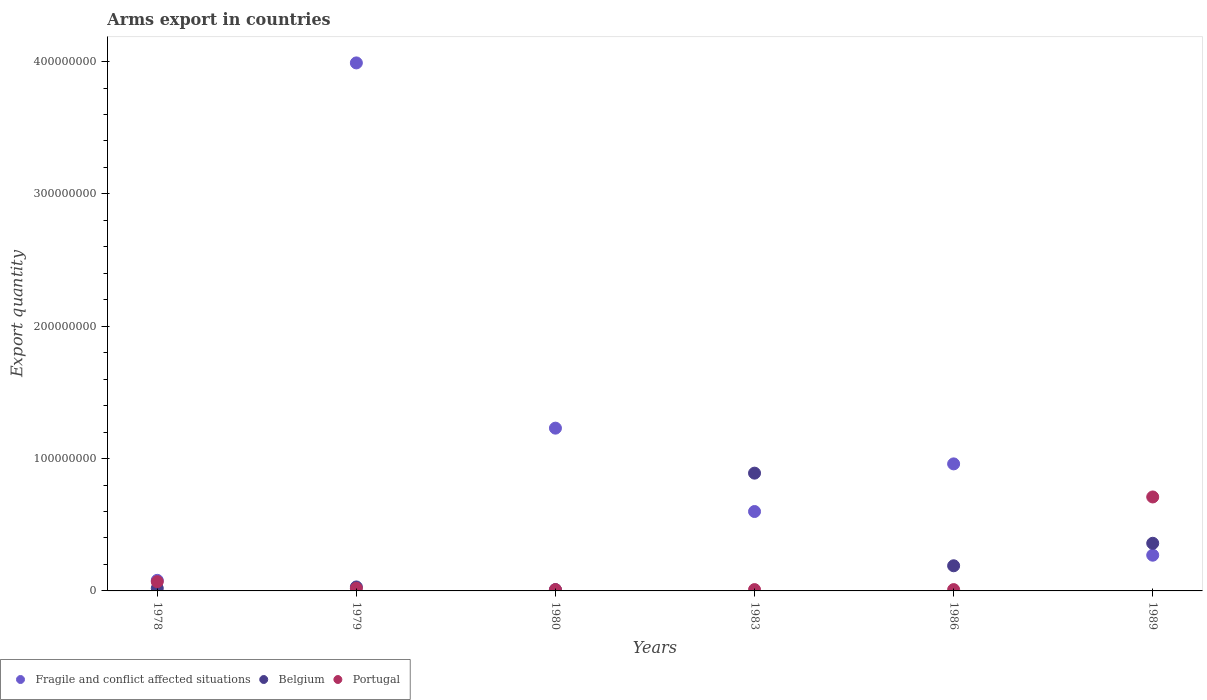Across all years, what is the maximum total arms export in Portugal?
Make the answer very short. 7.10e+07. Across all years, what is the minimum total arms export in Fragile and conflict affected situations?
Give a very brief answer. 8.00e+06. In which year was the total arms export in Fragile and conflict affected situations minimum?
Offer a terse response. 1978. What is the total total arms export in Portugal in the graph?
Offer a very short reply. 8.30e+07. What is the difference between the total arms export in Portugal in 1978 and that in 1989?
Your response must be concise. -6.40e+07. What is the difference between the total arms export in Fragile and conflict affected situations in 1979 and the total arms export in Belgium in 1978?
Offer a terse response. 3.97e+08. What is the average total arms export in Belgium per year?
Your answer should be compact. 2.50e+07. In the year 1989, what is the difference between the total arms export in Belgium and total arms export in Fragile and conflict affected situations?
Ensure brevity in your answer.  9.00e+06. What is the ratio of the total arms export in Portugal in 1978 to that in 1979?
Your answer should be compact. 3.5. Is the total arms export in Portugal in 1978 less than that in 1986?
Provide a short and direct response. No. What is the difference between the highest and the second highest total arms export in Fragile and conflict affected situations?
Offer a terse response. 2.76e+08. What is the difference between the highest and the lowest total arms export in Belgium?
Give a very brief answer. 8.80e+07. Is the total arms export in Fragile and conflict affected situations strictly greater than the total arms export in Belgium over the years?
Offer a very short reply. No. How many dotlines are there?
Offer a very short reply. 3. How many years are there in the graph?
Provide a succinct answer. 6. Does the graph contain any zero values?
Ensure brevity in your answer.  No. What is the title of the graph?
Offer a very short reply. Arms export in countries. Does "Bhutan" appear as one of the legend labels in the graph?
Make the answer very short. No. What is the label or title of the Y-axis?
Provide a succinct answer. Export quantity. What is the Export quantity in Belgium in 1978?
Provide a short and direct response. 2.00e+06. What is the Export quantity of Portugal in 1978?
Ensure brevity in your answer.  7.00e+06. What is the Export quantity of Fragile and conflict affected situations in 1979?
Your response must be concise. 3.99e+08. What is the Export quantity of Portugal in 1979?
Provide a short and direct response. 2.00e+06. What is the Export quantity of Fragile and conflict affected situations in 1980?
Provide a succinct answer. 1.23e+08. What is the Export quantity of Belgium in 1980?
Offer a terse response. 1.00e+06. What is the Export quantity of Portugal in 1980?
Give a very brief answer. 1.00e+06. What is the Export quantity of Fragile and conflict affected situations in 1983?
Keep it short and to the point. 6.00e+07. What is the Export quantity in Belgium in 1983?
Offer a very short reply. 8.90e+07. What is the Export quantity in Portugal in 1983?
Offer a terse response. 1.00e+06. What is the Export quantity in Fragile and conflict affected situations in 1986?
Your response must be concise. 9.60e+07. What is the Export quantity in Belgium in 1986?
Your answer should be compact. 1.90e+07. What is the Export quantity in Fragile and conflict affected situations in 1989?
Offer a terse response. 2.70e+07. What is the Export quantity in Belgium in 1989?
Offer a very short reply. 3.60e+07. What is the Export quantity of Portugal in 1989?
Offer a very short reply. 7.10e+07. Across all years, what is the maximum Export quantity in Fragile and conflict affected situations?
Provide a short and direct response. 3.99e+08. Across all years, what is the maximum Export quantity in Belgium?
Keep it short and to the point. 8.90e+07. Across all years, what is the maximum Export quantity in Portugal?
Offer a very short reply. 7.10e+07. Across all years, what is the minimum Export quantity in Fragile and conflict affected situations?
Your answer should be very brief. 8.00e+06. What is the total Export quantity of Fragile and conflict affected situations in the graph?
Your answer should be compact. 7.13e+08. What is the total Export quantity in Belgium in the graph?
Give a very brief answer. 1.50e+08. What is the total Export quantity in Portugal in the graph?
Provide a short and direct response. 8.30e+07. What is the difference between the Export quantity of Fragile and conflict affected situations in 1978 and that in 1979?
Keep it short and to the point. -3.91e+08. What is the difference between the Export quantity in Belgium in 1978 and that in 1979?
Your answer should be compact. -1.00e+06. What is the difference between the Export quantity in Fragile and conflict affected situations in 1978 and that in 1980?
Your response must be concise. -1.15e+08. What is the difference between the Export quantity of Portugal in 1978 and that in 1980?
Provide a succinct answer. 6.00e+06. What is the difference between the Export quantity of Fragile and conflict affected situations in 1978 and that in 1983?
Keep it short and to the point. -5.20e+07. What is the difference between the Export quantity of Belgium in 1978 and that in 1983?
Your answer should be compact. -8.70e+07. What is the difference between the Export quantity in Portugal in 1978 and that in 1983?
Give a very brief answer. 6.00e+06. What is the difference between the Export quantity in Fragile and conflict affected situations in 1978 and that in 1986?
Make the answer very short. -8.80e+07. What is the difference between the Export quantity of Belgium in 1978 and that in 1986?
Give a very brief answer. -1.70e+07. What is the difference between the Export quantity of Fragile and conflict affected situations in 1978 and that in 1989?
Offer a very short reply. -1.90e+07. What is the difference between the Export quantity of Belgium in 1978 and that in 1989?
Offer a terse response. -3.40e+07. What is the difference between the Export quantity in Portugal in 1978 and that in 1989?
Ensure brevity in your answer.  -6.40e+07. What is the difference between the Export quantity of Fragile and conflict affected situations in 1979 and that in 1980?
Your answer should be compact. 2.76e+08. What is the difference between the Export quantity in Belgium in 1979 and that in 1980?
Make the answer very short. 2.00e+06. What is the difference between the Export quantity in Portugal in 1979 and that in 1980?
Offer a very short reply. 1.00e+06. What is the difference between the Export quantity in Fragile and conflict affected situations in 1979 and that in 1983?
Keep it short and to the point. 3.39e+08. What is the difference between the Export quantity in Belgium in 1979 and that in 1983?
Your answer should be compact. -8.60e+07. What is the difference between the Export quantity in Portugal in 1979 and that in 1983?
Ensure brevity in your answer.  1.00e+06. What is the difference between the Export quantity in Fragile and conflict affected situations in 1979 and that in 1986?
Provide a short and direct response. 3.03e+08. What is the difference between the Export quantity in Belgium in 1979 and that in 1986?
Your answer should be very brief. -1.60e+07. What is the difference between the Export quantity in Fragile and conflict affected situations in 1979 and that in 1989?
Keep it short and to the point. 3.72e+08. What is the difference between the Export quantity in Belgium in 1979 and that in 1989?
Make the answer very short. -3.30e+07. What is the difference between the Export quantity of Portugal in 1979 and that in 1989?
Your response must be concise. -6.90e+07. What is the difference between the Export quantity in Fragile and conflict affected situations in 1980 and that in 1983?
Your answer should be compact. 6.30e+07. What is the difference between the Export quantity in Belgium in 1980 and that in 1983?
Keep it short and to the point. -8.80e+07. What is the difference between the Export quantity of Portugal in 1980 and that in 1983?
Your answer should be very brief. 0. What is the difference between the Export quantity of Fragile and conflict affected situations in 1980 and that in 1986?
Your answer should be compact. 2.70e+07. What is the difference between the Export quantity of Belgium in 1980 and that in 1986?
Give a very brief answer. -1.80e+07. What is the difference between the Export quantity in Portugal in 1980 and that in 1986?
Your answer should be very brief. 0. What is the difference between the Export quantity in Fragile and conflict affected situations in 1980 and that in 1989?
Ensure brevity in your answer.  9.60e+07. What is the difference between the Export quantity in Belgium in 1980 and that in 1989?
Your answer should be very brief. -3.50e+07. What is the difference between the Export quantity of Portugal in 1980 and that in 1989?
Provide a succinct answer. -7.00e+07. What is the difference between the Export quantity of Fragile and conflict affected situations in 1983 and that in 1986?
Provide a succinct answer. -3.60e+07. What is the difference between the Export quantity in Belgium in 1983 and that in 1986?
Keep it short and to the point. 7.00e+07. What is the difference between the Export quantity in Fragile and conflict affected situations in 1983 and that in 1989?
Your answer should be very brief. 3.30e+07. What is the difference between the Export quantity in Belgium in 1983 and that in 1989?
Provide a short and direct response. 5.30e+07. What is the difference between the Export quantity of Portugal in 1983 and that in 1989?
Offer a very short reply. -7.00e+07. What is the difference between the Export quantity of Fragile and conflict affected situations in 1986 and that in 1989?
Offer a very short reply. 6.90e+07. What is the difference between the Export quantity in Belgium in 1986 and that in 1989?
Offer a terse response. -1.70e+07. What is the difference between the Export quantity in Portugal in 1986 and that in 1989?
Your answer should be very brief. -7.00e+07. What is the difference between the Export quantity in Belgium in 1978 and the Export quantity in Portugal in 1979?
Offer a terse response. 0. What is the difference between the Export quantity in Fragile and conflict affected situations in 1978 and the Export quantity in Belgium in 1980?
Provide a succinct answer. 7.00e+06. What is the difference between the Export quantity in Fragile and conflict affected situations in 1978 and the Export quantity in Belgium in 1983?
Provide a short and direct response. -8.10e+07. What is the difference between the Export quantity of Belgium in 1978 and the Export quantity of Portugal in 1983?
Your response must be concise. 1.00e+06. What is the difference between the Export quantity in Fragile and conflict affected situations in 1978 and the Export quantity in Belgium in 1986?
Your answer should be compact. -1.10e+07. What is the difference between the Export quantity in Fragile and conflict affected situations in 1978 and the Export quantity in Portugal in 1986?
Provide a succinct answer. 7.00e+06. What is the difference between the Export quantity in Fragile and conflict affected situations in 1978 and the Export quantity in Belgium in 1989?
Make the answer very short. -2.80e+07. What is the difference between the Export quantity of Fragile and conflict affected situations in 1978 and the Export quantity of Portugal in 1989?
Offer a terse response. -6.30e+07. What is the difference between the Export quantity in Belgium in 1978 and the Export quantity in Portugal in 1989?
Offer a terse response. -6.90e+07. What is the difference between the Export quantity of Fragile and conflict affected situations in 1979 and the Export quantity of Belgium in 1980?
Offer a terse response. 3.98e+08. What is the difference between the Export quantity in Fragile and conflict affected situations in 1979 and the Export quantity in Portugal in 1980?
Your answer should be very brief. 3.98e+08. What is the difference between the Export quantity of Fragile and conflict affected situations in 1979 and the Export quantity of Belgium in 1983?
Offer a terse response. 3.10e+08. What is the difference between the Export quantity of Fragile and conflict affected situations in 1979 and the Export quantity of Portugal in 1983?
Provide a short and direct response. 3.98e+08. What is the difference between the Export quantity in Fragile and conflict affected situations in 1979 and the Export quantity in Belgium in 1986?
Your answer should be very brief. 3.80e+08. What is the difference between the Export quantity in Fragile and conflict affected situations in 1979 and the Export quantity in Portugal in 1986?
Offer a very short reply. 3.98e+08. What is the difference between the Export quantity of Fragile and conflict affected situations in 1979 and the Export quantity of Belgium in 1989?
Your answer should be very brief. 3.63e+08. What is the difference between the Export quantity of Fragile and conflict affected situations in 1979 and the Export quantity of Portugal in 1989?
Give a very brief answer. 3.28e+08. What is the difference between the Export quantity in Belgium in 1979 and the Export quantity in Portugal in 1989?
Provide a succinct answer. -6.80e+07. What is the difference between the Export quantity of Fragile and conflict affected situations in 1980 and the Export quantity of Belgium in 1983?
Offer a terse response. 3.40e+07. What is the difference between the Export quantity of Fragile and conflict affected situations in 1980 and the Export quantity of Portugal in 1983?
Give a very brief answer. 1.22e+08. What is the difference between the Export quantity of Belgium in 1980 and the Export quantity of Portugal in 1983?
Give a very brief answer. 0. What is the difference between the Export quantity in Fragile and conflict affected situations in 1980 and the Export quantity in Belgium in 1986?
Your response must be concise. 1.04e+08. What is the difference between the Export quantity in Fragile and conflict affected situations in 1980 and the Export quantity in Portugal in 1986?
Keep it short and to the point. 1.22e+08. What is the difference between the Export quantity of Belgium in 1980 and the Export quantity of Portugal in 1986?
Keep it short and to the point. 0. What is the difference between the Export quantity of Fragile and conflict affected situations in 1980 and the Export quantity of Belgium in 1989?
Provide a short and direct response. 8.70e+07. What is the difference between the Export quantity in Fragile and conflict affected situations in 1980 and the Export quantity in Portugal in 1989?
Offer a terse response. 5.20e+07. What is the difference between the Export quantity of Belgium in 1980 and the Export quantity of Portugal in 1989?
Keep it short and to the point. -7.00e+07. What is the difference between the Export quantity of Fragile and conflict affected situations in 1983 and the Export quantity of Belgium in 1986?
Keep it short and to the point. 4.10e+07. What is the difference between the Export quantity of Fragile and conflict affected situations in 1983 and the Export quantity of Portugal in 1986?
Your response must be concise. 5.90e+07. What is the difference between the Export quantity of Belgium in 1983 and the Export quantity of Portugal in 1986?
Offer a very short reply. 8.80e+07. What is the difference between the Export quantity of Fragile and conflict affected situations in 1983 and the Export quantity of Belgium in 1989?
Provide a short and direct response. 2.40e+07. What is the difference between the Export quantity of Fragile and conflict affected situations in 1983 and the Export quantity of Portugal in 1989?
Provide a short and direct response. -1.10e+07. What is the difference between the Export quantity in Belgium in 1983 and the Export quantity in Portugal in 1989?
Make the answer very short. 1.80e+07. What is the difference between the Export quantity of Fragile and conflict affected situations in 1986 and the Export quantity of Belgium in 1989?
Your answer should be compact. 6.00e+07. What is the difference between the Export quantity in Fragile and conflict affected situations in 1986 and the Export quantity in Portugal in 1989?
Ensure brevity in your answer.  2.50e+07. What is the difference between the Export quantity of Belgium in 1986 and the Export quantity of Portugal in 1989?
Offer a terse response. -5.20e+07. What is the average Export quantity in Fragile and conflict affected situations per year?
Your response must be concise. 1.19e+08. What is the average Export quantity of Belgium per year?
Provide a succinct answer. 2.50e+07. What is the average Export quantity in Portugal per year?
Your answer should be very brief. 1.38e+07. In the year 1978, what is the difference between the Export quantity of Fragile and conflict affected situations and Export quantity of Belgium?
Your answer should be compact. 6.00e+06. In the year 1978, what is the difference between the Export quantity of Fragile and conflict affected situations and Export quantity of Portugal?
Make the answer very short. 1.00e+06. In the year 1978, what is the difference between the Export quantity in Belgium and Export quantity in Portugal?
Offer a terse response. -5.00e+06. In the year 1979, what is the difference between the Export quantity of Fragile and conflict affected situations and Export quantity of Belgium?
Keep it short and to the point. 3.96e+08. In the year 1979, what is the difference between the Export quantity in Fragile and conflict affected situations and Export quantity in Portugal?
Give a very brief answer. 3.97e+08. In the year 1979, what is the difference between the Export quantity in Belgium and Export quantity in Portugal?
Your answer should be very brief. 1.00e+06. In the year 1980, what is the difference between the Export quantity in Fragile and conflict affected situations and Export quantity in Belgium?
Your response must be concise. 1.22e+08. In the year 1980, what is the difference between the Export quantity in Fragile and conflict affected situations and Export quantity in Portugal?
Make the answer very short. 1.22e+08. In the year 1980, what is the difference between the Export quantity of Belgium and Export quantity of Portugal?
Your answer should be compact. 0. In the year 1983, what is the difference between the Export quantity in Fragile and conflict affected situations and Export quantity in Belgium?
Your answer should be very brief. -2.90e+07. In the year 1983, what is the difference between the Export quantity of Fragile and conflict affected situations and Export quantity of Portugal?
Make the answer very short. 5.90e+07. In the year 1983, what is the difference between the Export quantity in Belgium and Export quantity in Portugal?
Make the answer very short. 8.80e+07. In the year 1986, what is the difference between the Export quantity in Fragile and conflict affected situations and Export quantity in Belgium?
Provide a short and direct response. 7.70e+07. In the year 1986, what is the difference between the Export quantity of Fragile and conflict affected situations and Export quantity of Portugal?
Keep it short and to the point. 9.50e+07. In the year 1986, what is the difference between the Export quantity in Belgium and Export quantity in Portugal?
Provide a succinct answer. 1.80e+07. In the year 1989, what is the difference between the Export quantity of Fragile and conflict affected situations and Export quantity of Belgium?
Provide a succinct answer. -9.00e+06. In the year 1989, what is the difference between the Export quantity in Fragile and conflict affected situations and Export quantity in Portugal?
Provide a succinct answer. -4.40e+07. In the year 1989, what is the difference between the Export quantity of Belgium and Export quantity of Portugal?
Provide a short and direct response. -3.50e+07. What is the ratio of the Export quantity of Fragile and conflict affected situations in 1978 to that in 1979?
Give a very brief answer. 0.02. What is the ratio of the Export quantity in Belgium in 1978 to that in 1979?
Your response must be concise. 0.67. What is the ratio of the Export quantity of Portugal in 1978 to that in 1979?
Ensure brevity in your answer.  3.5. What is the ratio of the Export quantity in Fragile and conflict affected situations in 1978 to that in 1980?
Offer a very short reply. 0.07. What is the ratio of the Export quantity of Belgium in 1978 to that in 1980?
Provide a succinct answer. 2. What is the ratio of the Export quantity of Fragile and conflict affected situations in 1978 to that in 1983?
Offer a terse response. 0.13. What is the ratio of the Export quantity in Belgium in 1978 to that in 1983?
Ensure brevity in your answer.  0.02. What is the ratio of the Export quantity of Fragile and conflict affected situations in 1978 to that in 1986?
Make the answer very short. 0.08. What is the ratio of the Export quantity of Belgium in 1978 to that in 1986?
Ensure brevity in your answer.  0.11. What is the ratio of the Export quantity of Fragile and conflict affected situations in 1978 to that in 1989?
Provide a succinct answer. 0.3. What is the ratio of the Export quantity in Belgium in 1978 to that in 1989?
Offer a terse response. 0.06. What is the ratio of the Export quantity in Portugal in 1978 to that in 1989?
Provide a succinct answer. 0.1. What is the ratio of the Export quantity in Fragile and conflict affected situations in 1979 to that in 1980?
Provide a succinct answer. 3.24. What is the ratio of the Export quantity in Belgium in 1979 to that in 1980?
Ensure brevity in your answer.  3. What is the ratio of the Export quantity of Portugal in 1979 to that in 1980?
Provide a short and direct response. 2. What is the ratio of the Export quantity of Fragile and conflict affected situations in 1979 to that in 1983?
Your answer should be very brief. 6.65. What is the ratio of the Export quantity in Belgium in 1979 to that in 1983?
Offer a very short reply. 0.03. What is the ratio of the Export quantity in Fragile and conflict affected situations in 1979 to that in 1986?
Ensure brevity in your answer.  4.16. What is the ratio of the Export quantity in Belgium in 1979 to that in 1986?
Your answer should be very brief. 0.16. What is the ratio of the Export quantity in Fragile and conflict affected situations in 1979 to that in 1989?
Provide a succinct answer. 14.78. What is the ratio of the Export quantity in Belgium in 1979 to that in 1989?
Your answer should be very brief. 0.08. What is the ratio of the Export quantity of Portugal in 1979 to that in 1989?
Make the answer very short. 0.03. What is the ratio of the Export quantity in Fragile and conflict affected situations in 1980 to that in 1983?
Make the answer very short. 2.05. What is the ratio of the Export quantity of Belgium in 1980 to that in 1983?
Ensure brevity in your answer.  0.01. What is the ratio of the Export quantity in Portugal in 1980 to that in 1983?
Ensure brevity in your answer.  1. What is the ratio of the Export quantity in Fragile and conflict affected situations in 1980 to that in 1986?
Provide a succinct answer. 1.28. What is the ratio of the Export quantity in Belgium in 1980 to that in 1986?
Give a very brief answer. 0.05. What is the ratio of the Export quantity of Portugal in 1980 to that in 1986?
Give a very brief answer. 1. What is the ratio of the Export quantity of Fragile and conflict affected situations in 1980 to that in 1989?
Keep it short and to the point. 4.56. What is the ratio of the Export quantity in Belgium in 1980 to that in 1989?
Offer a terse response. 0.03. What is the ratio of the Export quantity in Portugal in 1980 to that in 1989?
Give a very brief answer. 0.01. What is the ratio of the Export quantity in Belgium in 1983 to that in 1986?
Keep it short and to the point. 4.68. What is the ratio of the Export quantity in Portugal in 1983 to that in 1986?
Provide a short and direct response. 1. What is the ratio of the Export quantity in Fragile and conflict affected situations in 1983 to that in 1989?
Offer a terse response. 2.22. What is the ratio of the Export quantity in Belgium in 1983 to that in 1989?
Provide a short and direct response. 2.47. What is the ratio of the Export quantity in Portugal in 1983 to that in 1989?
Offer a very short reply. 0.01. What is the ratio of the Export quantity of Fragile and conflict affected situations in 1986 to that in 1989?
Your answer should be very brief. 3.56. What is the ratio of the Export quantity of Belgium in 1986 to that in 1989?
Give a very brief answer. 0.53. What is the ratio of the Export quantity of Portugal in 1986 to that in 1989?
Ensure brevity in your answer.  0.01. What is the difference between the highest and the second highest Export quantity of Fragile and conflict affected situations?
Provide a succinct answer. 2.76e+08. What is the difference between the highest and the second highest Export quantity of Belgium?
Your response must be concise. 5.30e+07. What is the difference between the highest and the second highest Export quantity in Portugal?
Your answer should be very brief. 6.40e+07. What is the difference between the highest and the lowest Export quantity of Fragile and conflict affected situations?
Make the answer very short. 3.91e+08. What is the difference between the highest and the lowest Export quantity of Belgium?
Provide a short and direct response. 8.80e+07. What is the difference between the highest and the lowest Export quantity in Portugal?
Give a very brief answer. 7.00e+07. 